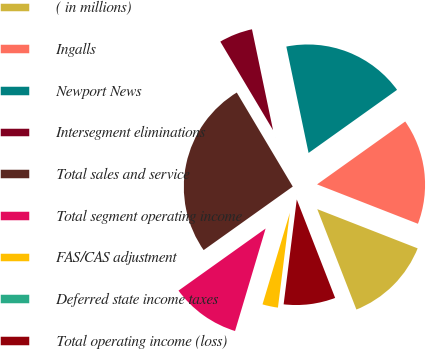Convert chart to OTSL. <chart><loc_0><loc_0><loc_500><loc_500><pie_chart><fcel>( in millions)<fcel>Ingalls<fcel>Newport News<fcel>Intersegment eliminations<fcel>Total sales and service<fcel>Total segment operating income<fcel>FAS/CAS adjustment<fcel>Deferred state income taxes<fcel>Total operating income (loss)<nl><fcel>13.16%<fcel>15.79%<fcel>18.42%<fcel>5.27%<fcel>26.31%<fcel>10.53%<fcel>2.63%<fcel>0.0%<fcel>7.9%<nl></chart> 